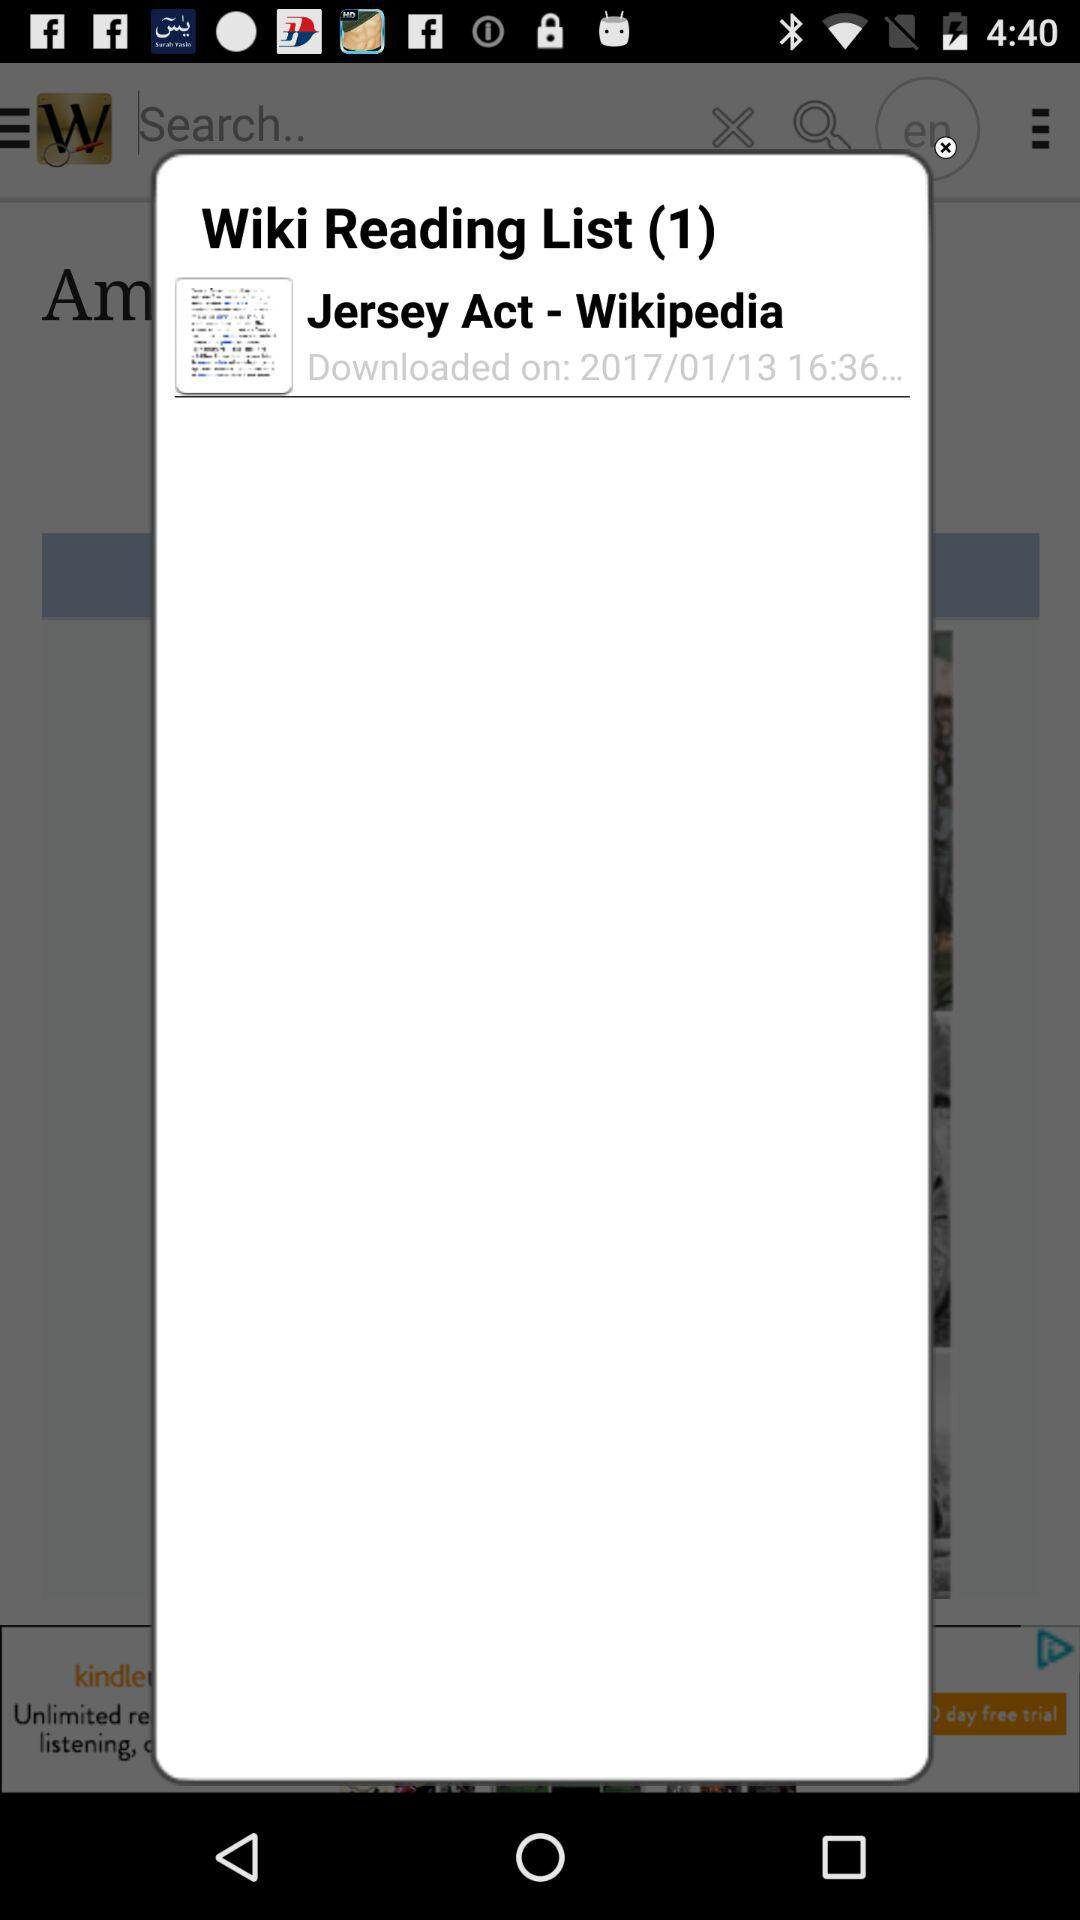What is the name of the act? The name of the act is Jersey. 